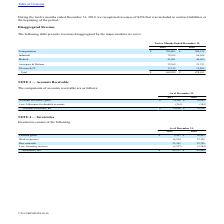From Cts Corporation's financial document, Which years does the table provide information for the components of the accounts receivables for the company? The document shows two values: 2019 and 2018. From the document: "2019 2018 2019 2018..." Also, What was the amount of gross accounts receivables in 2019? According to the financial document, 78,269 (in thousands). The relevant text states: "Accounts receivable, gross $ 78,269 $ 79,902..." Also, What was the amount of net accounts receivables in 2018? According to the financial document, 79,518 (in thousands). The relevant text states: "Accounts receivable, net $ 78,008 $ 79,518..." Also, can you calculate: What was the change in gross accounts receivables between 2018 and 2019? Based on the calculation: 78,269-79,902, the result is -1633 (in thousands). This is based on the information: "Accounts receivable, gross $ 78,269 $ 79,902 Accounts receivable, gross $ 78,269 $ 79,902..." The key data points involved are: 78,269, 79,902. Also, How many years did net accounts receivables exceed $75,000 thousand? Counting the relevant items in the document: 2019, 2018, I find 2 instances. The key data points involved are: 2018, 2019. Also, can you calculate: What was the percentage change in net accounts receivables between 2018 and 2019? To answer this question, I need to perform calculations using the financial data. The calculation is: (78,008-79,518)/79,518, which equals -1.9 (percentage). This is based on the information: "Accounts receivable, net $ 78,008 $ 79,518 Accounts receivable, net $ 78,008 $ 79,518..." The key data points involved are: 78,008, 79,518. 